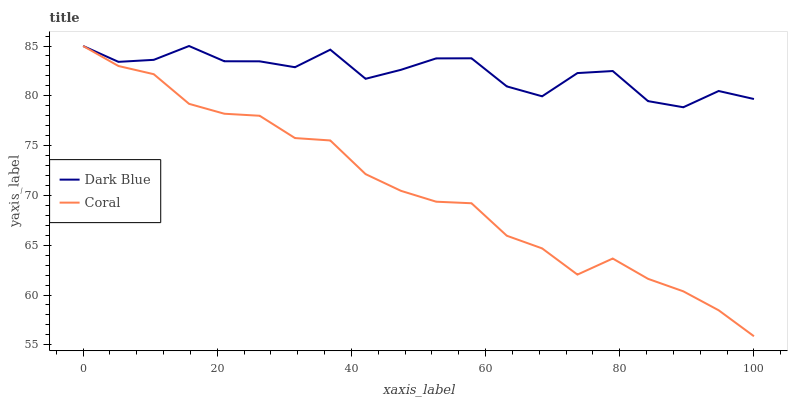Does Coral have the minimum area under the curve?
Answer yes or no. Yes. Does Dark Blue have the maximum area under the curve?
Answer yes or no. Yes. Does Coral have the maximum area under the curve?
Answer yes or no. No. Is Coral the smoothest?
Answer yes or no. Yes. Is Dark Blue the roughest?
Answer yes or no. Yes. Is Coral the roughest?
Answer yes or no. No. Does Coral have the lowest value?
Answer yes or no. Yes. Does Coral have the highest value?
Answer yes or no. Yes. Does Coral intersect Dark Blue?
Answer yes or no. Yes. Is Coral less than Dark Blue?
Answer yes or no. No. Is Coral greater than Dark Blue?
Answer yes or no. No. 